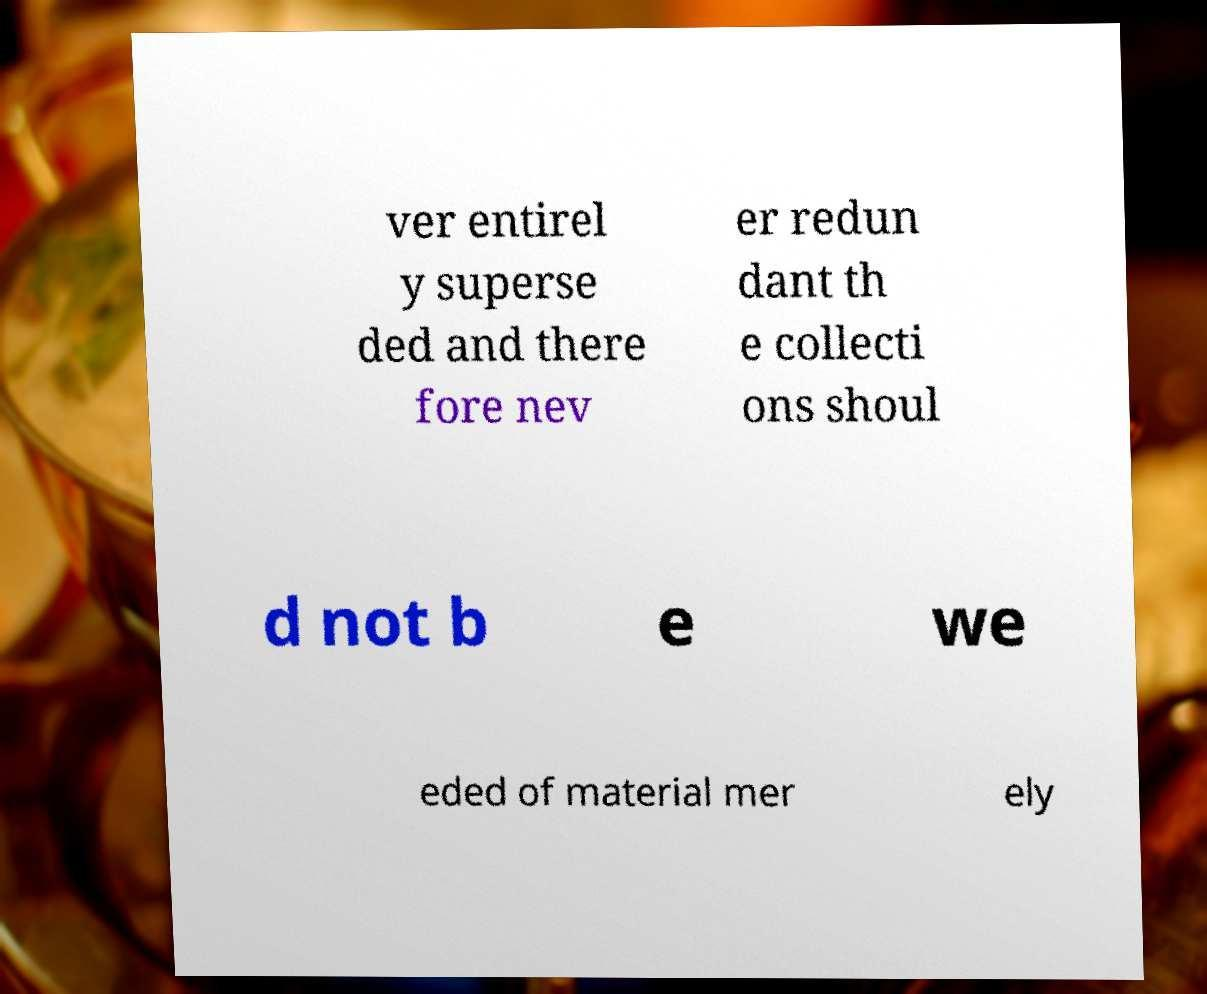What messages or text are displayed in this image? I need them in a readable, typed format. ver entirel y superse ded and there fore nev er redun dant th e collecti ons shoul d not b e we eded of material mer ely 